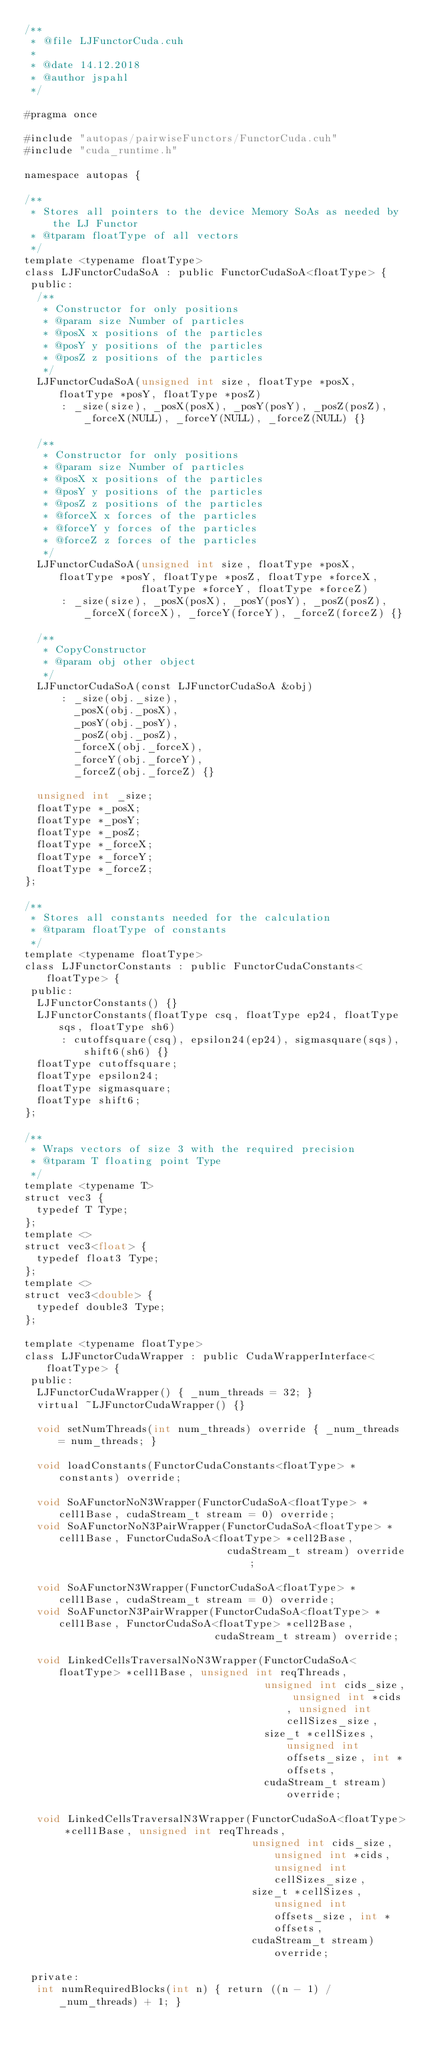<code> <loc_0><loc_0><loc_500><loc_500><_Cuda_>/**
 * @file LJFunctorCuda.cuh
 *
 * @date 14.12.2018
 * @author jspahl
 */

#pragma once

#include "autopas/pairwiseFunctors/FunctorCuda.cuh"
#include "cuda_runtime.h"

namespace autopas {

/**
 * Stores all pointers to the device Memory SoAs as needed by the LJ Functor
 * @tparam floatType of all vectors
 */
template <typename floatType>
class LJFunctorCudaSoA : public FunctorCudaSoA<floatType> {
 public:
  /**
   * Constructor for only positions
   * @param size Number of particles
   * @posX x positions of the particles
   * @posY y positions of the particles
   * @posZ z positions of the particles
   */
  LJFunctorCudaSoA(unsigned int size, floatType *posX, floatType *posY, floatType *posZ)
      : _size(size), _posX(posX), _posY(posY), _posZ(posZ), _forceX(NULL), _forceY(NULL), _forceZ(NULL) {}

  /**
   * Constructor for only positions
   * @param size Number of particles
   * @posX x positions of the particles
   * @posY y positions of the particles
   * @posZ z positions of the particles
   * @forceX x forces of the particles
   * @forceY y forces of the particles
   * @forceZ z forces of the particles
   */
  LJFunctorCudaSoA(unsigned int size, floatType *posX, floatType *posY, floatType *posZ, floatType *forceX,
                   floatType *forceY, floatType *forceZ)
      : _size(size), _posX(posX), _posY(posY), _posZ(posZ), _forceX(forceX), _forceY(forceY), _forceZ(forceZ) {}

  /**
   * CopyConstructor
   * @param obj other object
   */
  LJFunctorCudaSoA(const LJFunctorCudaSoA &obj)
      : _size(obj._size),
        _posX(obj._posX),
        _posY(obj._posY),
        _posZ(obj._posZ),
        _forceX(obj._forceX),
        _forceY(obj._forceY),
        _forceZ(obj._forceZ) {}

  unsigned int _size;
  floatType *_posX;
  floatType *_posY;
  floatType *_posZ;
  floatType *_forceX;
  floatType *_forceY;
  floatType *_forceZ;
};

/**
 * Stores all constants needed for the calculation
 * @tparam floatType of constants
 */
template <typename floatType>
class LJFunctorConstants : public FunctorCudaConstants<floatType> {
 public:
  LJFunctorConstants() {}
  LJFunctorConstants(floatType csq, floatType ep24, floatType sqs, floatType sh6)
      : cutoffsquare(csq), epsilon24(ep24), sigmasquare(sqs), shift6(sh6) {}
  floatType cutoffsquare;
  floatType epsilon24;
  floatType sigmasquare;
  floatType shift6;
};

/**
 * Wraps vectors of size 3 with the required precision
 * @tparam T floating point Type
 */
template <typename T>
struct vec3 {
  typedef T Type;
};
template <>
struct vec3<float> {
  typedef float3 Type;
};
template <>
struct vec3<double> {
  typedef double3 Type;
};

template <typename floatType>
class LJFunctorCudaWrapper : public CudaWrapperInterface<floatType> {
 public:
  LJFunctorCudaWrapper() { _num_threads = 32; }
  virtual ~LJFunctorCudaWrapper() {}

  void setNumThreads(int num_threads) override { _num_threads = num_threads; }

  void loadConstants(FunctorCudaConstants<floatType> *constants) override;

  void SoAFunctorNoN3Wrapper(FunctorCudaSoA<floatType> *cell1Base, cudaStream_t stream = 0) override;
  void SoAFunctorNoN3PairWrapper(FunctorCudaSoA<floatType> *cell1Base, FunctorCudaSoA<floatType> *cell2Base,
                                 cudaStream_t stream) override;

  void SoAFunctorN3Wrapper(FunctorCudaSoA<floatType> *cell1Base, cudaStream_t stream = 0) override;
  void SoAFunctorN3PairWrapper(FunctorCudaSoA<floatType> *cell1Base, FunctorCudaSoA<floatType> *cell2Base,
                               cudaStream_t stream) override;

  void LinkedCellsTraversalNoN3Wrapper(FunctorCudaSoA<floatType> *cell1Base, unsigned int reqThreads,
                                       unsigned int cids_size, unsigned int *cids, unsigned int cellSizes_size,
                                       size_t *cellSizes, unsigned int offsets_size, int *offsets,
                                       cudaStream_t stream) override;

  void LinkedCellsTraversalN3Wrapper(FunctorCudaSoA<floatType> *cell1Base, unsigned int reqThreads,
                                     unsigned int cids_size, unsigned int *cids, unsigned int cellSizes_size,
                                     size_t *cellSizes, unsigned int offsets_size, int *offsets,
                                     cudaStream_t stream) override;

 private:
  int numRequiredBlocks(int n) { return ((n - 1) / _num_threads) + 1; }
</code> 